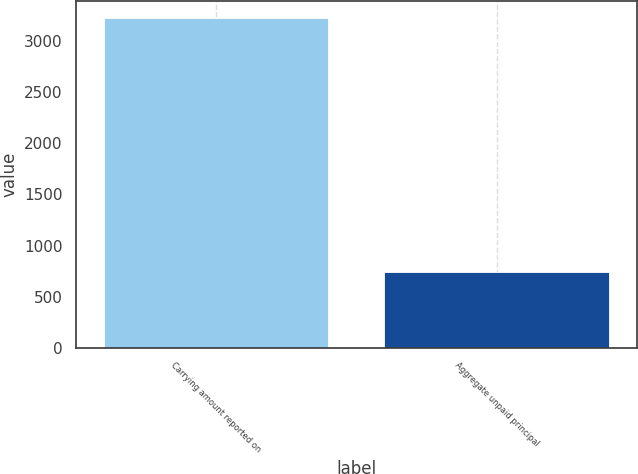<chart> <loc_0><loc_0><loc_500><loc_500><bar_chart><fcel>Carrying amount reported on<fcel>Aggregate unpaid principal<nl><fcel>3224<fcel>741<nl></chart> 